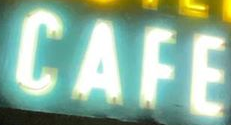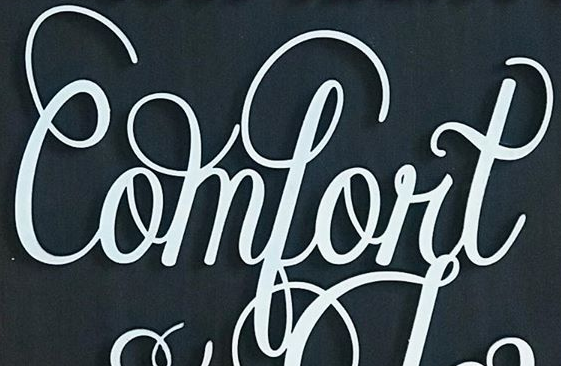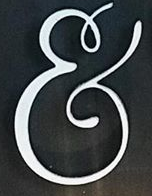What words can you see in these images in sequence, separated by a semicolon? CAFE; Comfort; & 